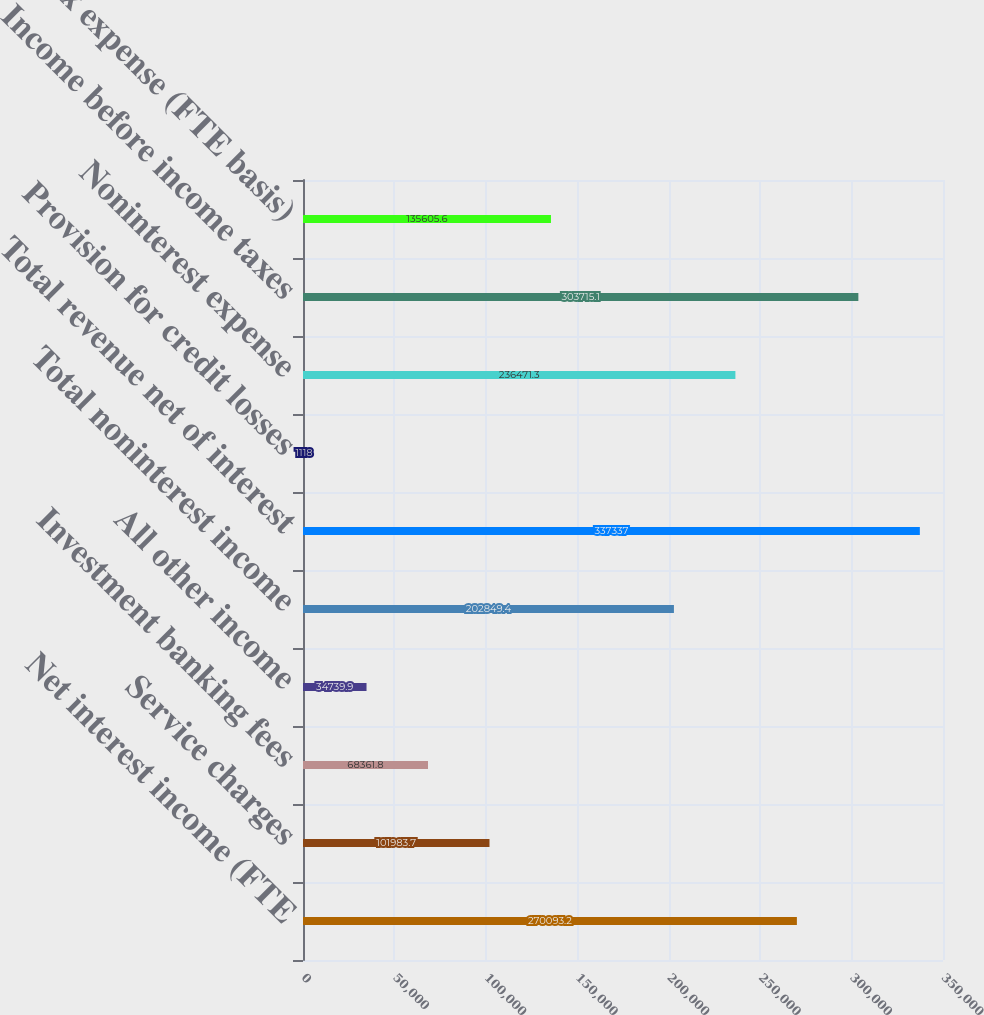Convert chart to OTSL. <chart><loc_0><loc_0><loc_500><loc_500><bar_chart><fcel>Net interest income (FTE<fcel>Service charges<fcel>Investment banking fees<fcel>All other income<fcel>Total noninterest income<fcel>Total revenue net of interest<fcel>Provision for credit losses<fcel>Noninterest expense<fcel>Income before income taxes<fcel>Income tax expense (FTE basis)<nl><fcel>270093<fcel>101984<fcel>68361.8<fcel>34739.9<fcel>202849<fcel>337337<fcel>1118<fcel>236471<fcel>303715<fcel>135606<nl></chart> 